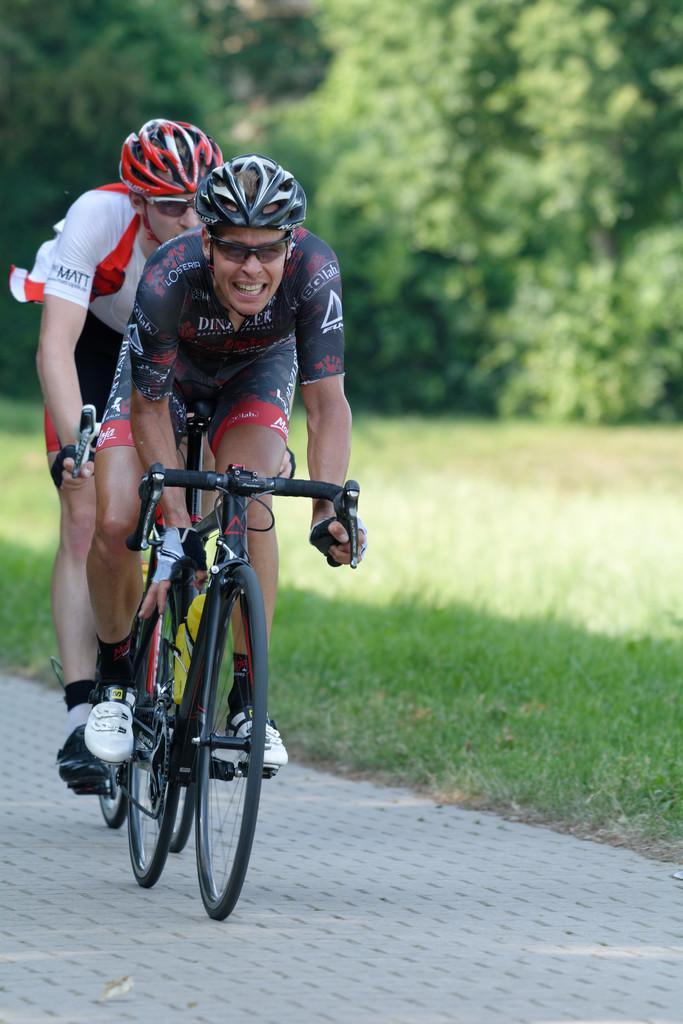How would you summarize this image in a sentence or two? In this image I can see two people riding the bicycle. These people are wearing the different color dresses and also helmets. To the side of these people I can see the grass and the trees. 